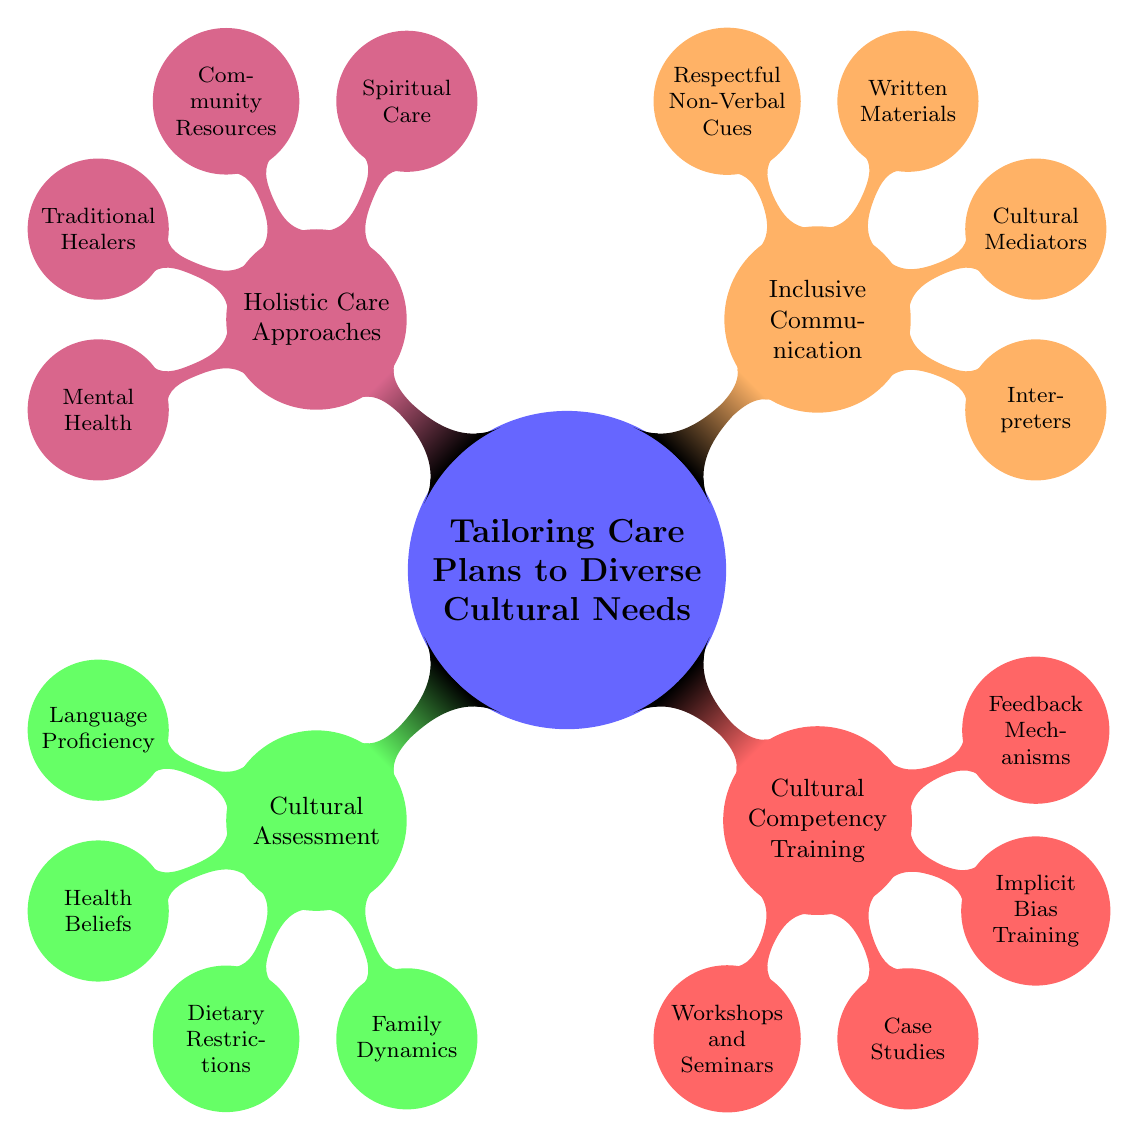What are the four main categories in the mind map? The main categories are found directly under the central node "Tailoring Care Plans to Diverse Cultural Needs." They are Cultural Assessment, Cultural Competency Training, Inclusive Communication, and Holistic Care Approaches.
Answer: Cultural Assessment, Cultural Competency Training, Inclusive Communication, Holistic Care Approaches How many nodes are under the Cultural Assessment category? By counting the child nodes directly connected to the Cultural Assessment node, we can see that there are four child nodes: Language Proficiency, Health Beliefs, Dietary Restrictions, and Family Dynamics.
Answer: 4 Which category includes training on recognizing bias? The Implicit Bias Training is located under the Cultural Competency Training category. This directly associates the training with that category.
Answer: Cultural Competency Training List the type of communication support provided for non-English-speaking patients. Interpreters are specifically mentioned as a support tool for non-English-speaking patients, highlighting that they are employed to facilitate communication.
Answer: Interpreters What is the focus of the Holistic Care Approaches category? This category encompasses multiple aspects of care, specifically addressing spiritual practices, community resources, the role of traditional healers, and cultural sensitivities in mental health. It coordinates considerations into holistic care tailored to culture.
Answer: Spiritual Care, Community Resources, Traditional Healers, Mental Health What does the Cultural Assessment node prioritize understanding in healthcare? The Cultural Assessment node focuses on understanding various aspects related to a patient's culture, specifically health beliefs and traditional practices, to tailor care effectively.
Answer: Health Beliefs Which methods are suggested for enhancing cultural competency in providers? The Cultural Competency Training category includes Workshops and Seminars, Case Studies, Implicit Bias Training, and Feedback Mechanisms to enhance cultural competency in healthcare providers.
Answer: Workshops and Seminars, Case Studies, Implicit Bias Training, Feedback Mechanisms How is family structure relevant in the Cultural Assessment? Family Dynamics is a node that specifically addresses how family roles impact healthcare decision-making, underscoring the importance of cultural understanding of family structures.
Answer: Family Dynamics What role do cultural mediators play in healthcare according to the diagram? Cultural mediators are employed to bridge communication gaps between healthcare providers and patients, facilitating better understanding and care outcomes for diverse populations.
Answer: Cultural Mediators 